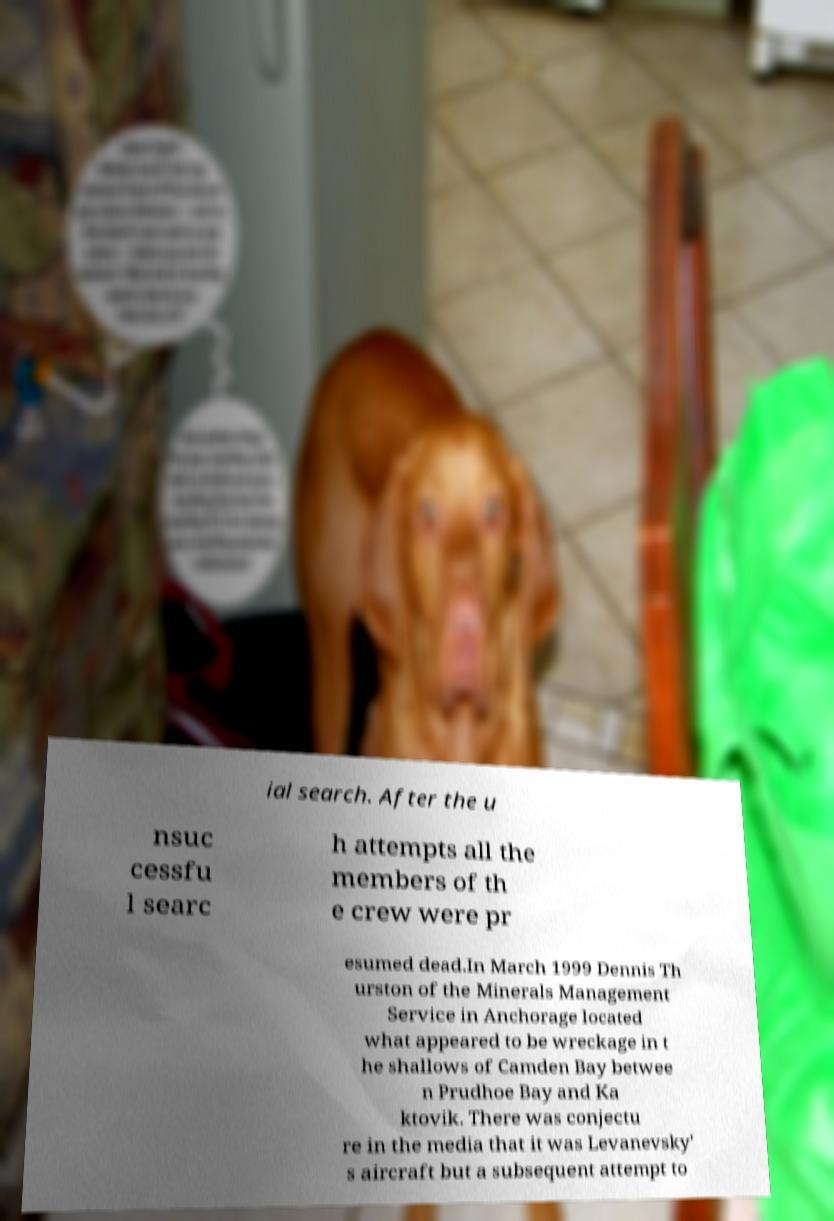Please identify and transcribe the text found in this image. ial search. After the u nsuc cessfu l searc h attempts all the members of th e crew were pr esumed dead.In March 1999 Dennis Th urston of the Minerals Management Service in Anchorage located what appeared to be wreckage in t he shallows of Camden Bay betwee n Prudhoe Bay and Ka ktovik. There was conjectu re in the media that it was Levanevsky' s aircraft but a subsequent attempt to 